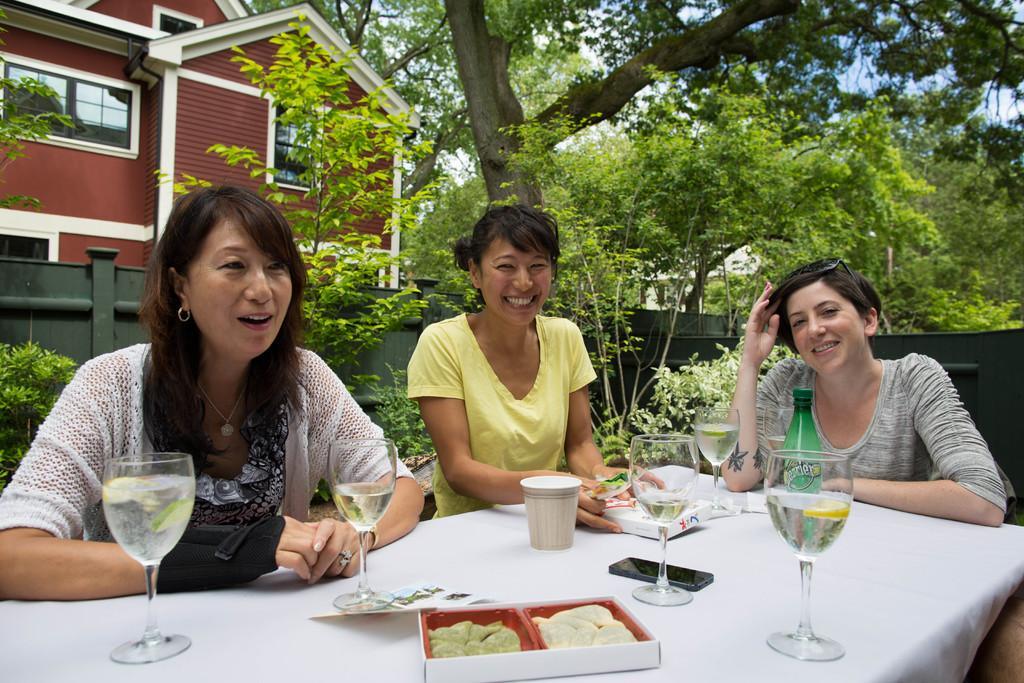In one or two sentences, can you explain what this image depicts? In this picture outside of the house. There are three people. They are sitting on a chairs. On the right side we have a person. She is wearing a spectacle. There is a table,. There is a glass,paper,box on a table. We can see in background trees,building ,window and sky. 